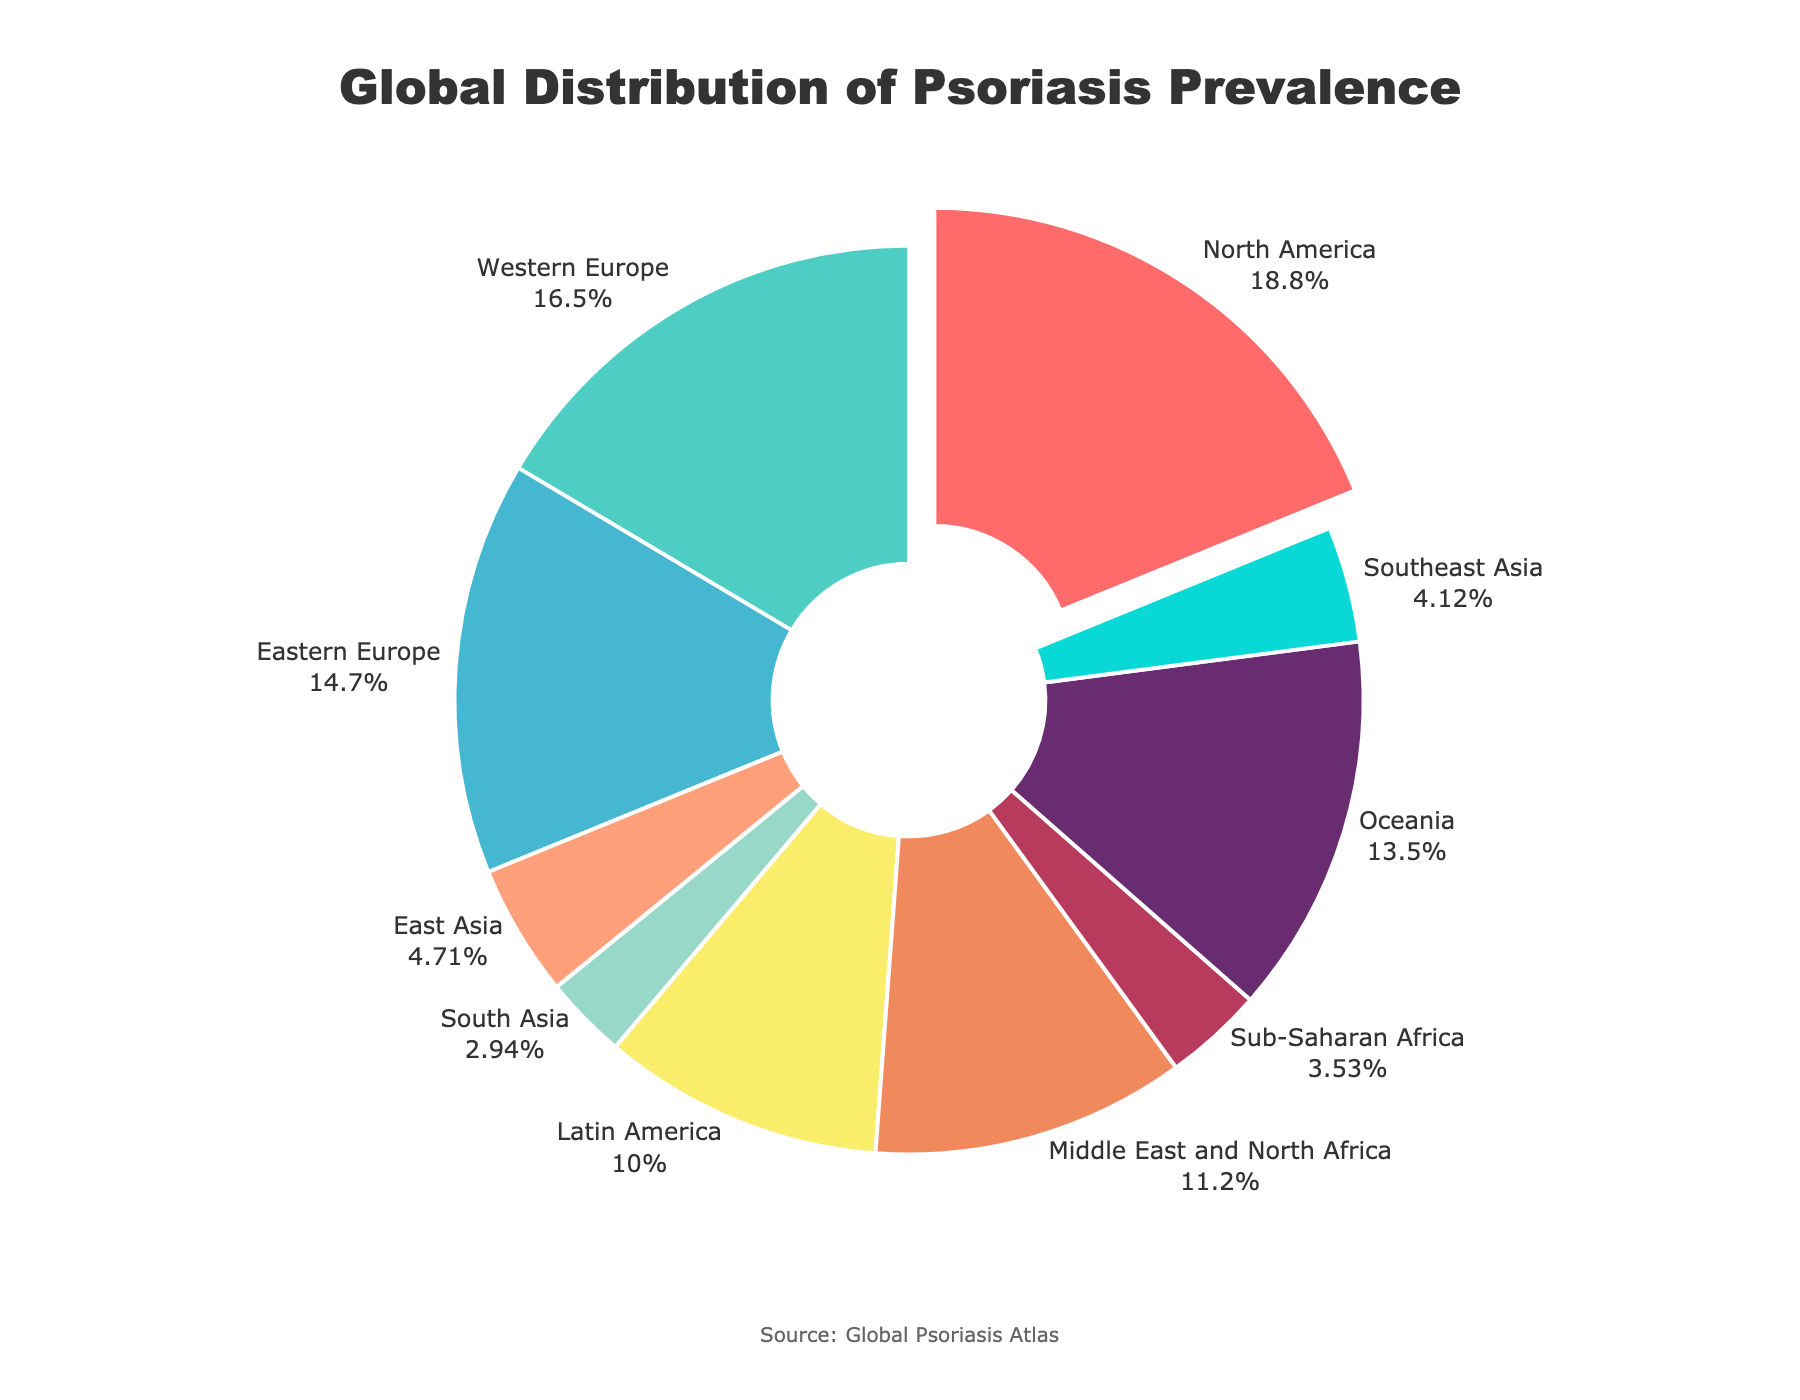Which region has the highest prevalence of psoriasis? Look for the region with the slice that is pulled out and has the highest percentage on the chart. North America has 3.2%, which is the highest.
Answer: North America What is the combined prevalence percentage of psoriasis in regions with less than 1% prevalence? Identify regions with less than 1% (East Asia: 0.8%, South Asia: 0.5%, Sub-Saharan Africa: 0.6%, Southeast Asia: 0.7%). Sum these percentages: 0.8 + 0.5 + 0.6 + 0.7 = 2.6%.
Answer: 2.6% Which regions have psoriasis prevalence greater than 2% but less than 3%? Identify the regions with prevalence between 2% and 3% (Western Europe: 2.8%, Oceania: 2.3%).
Answer: Western Europe and Oceania Is the prevalence of psoriasis in Latin America greater than that in Sub-Saharan Africa? Compare the two regions: Latin America's prevalence is 1.7%, and Sub-Saharan Africa's is 0.6%. 1.7% is greater than 0.6%.
Answer: Yes How much higher is the psoriasis prevalence in North America compared to East Asia? Subtract East Asia's prevalence from North America's: 3.2% - 0.8% = 2.4%.
Answer: 2.4% Which region is represented by the light blue section? Check the figure for a light blue section and its corresponding label, which is Oceania with 2.3%.
Answer: Oceania Rank the top three regions by psoriasis prevalence. List regions in descending order of prevalence: North America (3.2%), Western Europe (2.8%), and Eastern Europe (2.5%).
Answer: North America, Western Europe, Eastern Europe What is the average prevalence of psoriasis in North America and Western Europe? Add the prevalence percentages of North America (3.2%) and Western Europe (2.8%), then divide by 2. (3.2 + 2.8) / 2 = 3.0%.
Answer: 3.0% Which has a higher prevalence of psoriasis: the Middle East & North Africa or Latin America? Compare the prevalence: Middle East & North Africa has 1.9%, and Latin America has 1.7%. 1.9% is higher than 1.7%.
Answer: Middle East & North Africa 